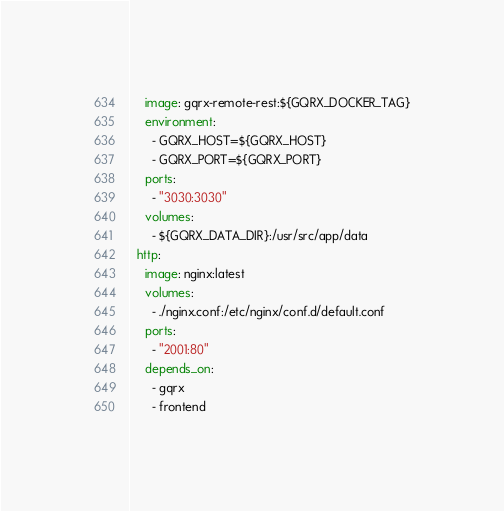Convert code to text. <code><loc_0><loc_0><loc_500><loc_500><_YAML_>    image: gqrx-remote-rest:${GQRX_DOCKER_TAG}
    environment:
      - GQRX_HOST=${GQRX_HOST}
      - GQRX_PORT=${GQRX_PORT} 
    ports:
      - "3030:3030"
    volumes:
      - ${GQRX_DATA_DIR}:/usr/src/app/data
  http:
    image: nginx:latest
    volumes:
      - ./nginx.conf:/etc/nginx/conf.d/default.conf
    ports:
      - "2001:80"
    depends_on:
      - gqrx
      - frontend</code> 